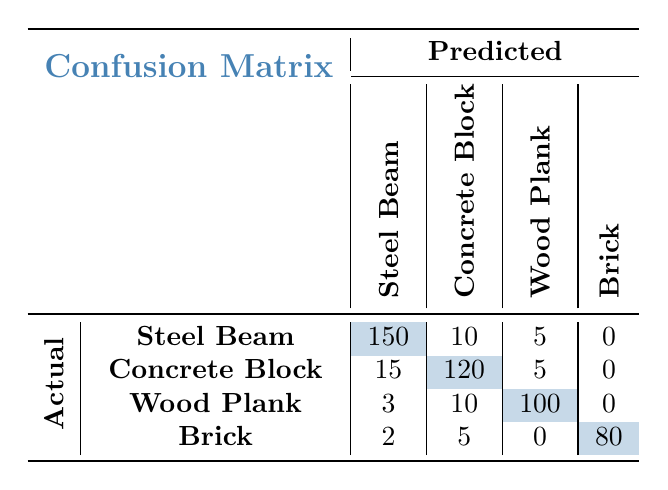What is the predicted outcome for “Steel Beam” when the actual outcome is also “Steel Beam”? The table shows that when the actual outcome is “Steel Beam”, the predicted outcome is also “Steel Beam” for 150 cases.
Answer: 150 What is the total count of "Concrete Block" actual outcomes predicted as "Wood Plank"? The table indicates that when the actual outcome is "Concrete Block", it was predicted as "Wood Plank" for 5 cases.
Answer: 5 What is the total number of actual "Wood Plank" loads predicted as something else (not "Wood Plank")? From the table, actual “Wood Plank” loads predicted as other materials are 3 (predicted as “Steel Beam”) + 10 (predicted as “Concrete Block”) = 13.
Answer: 13 Did any "Brick" loads get predicted accurately? The table shows that the actual "Brick" loads were predicted correctly for 80 cases. Hence, yes, there were accurate predictions.
Answer: Yes What is the overall accuracy for predicting "Concrete Block" loads? To calculate overall accuracy for "Concrete Block," we consider the correctly predicted outcomes (120) out of the total actual outcomes (120 + 15 + 5 = 140). So, the accuracy is 120/140 = 0.857 or 85.7%.
Answer: 85.7% How many total materials were predicted as “Steel Beam” regardless of the actual outcome? By adding together all cases predicted as "Steel Beam" from each actual category: 150 (Steel Beam) + 15 (Concrete Block) + 3 (Wood Plank) + 2 (Brick) = 170 predicted as "Steel Beam".
Answer: 170 Which material had the highest number of accurate predictions in this matrix? "Wood Plank" had the highest number of accurate predictions at 100 cases, as shown in the table.
Answer: Wood Plank What is the difference in count between actual "Concrete Block" and predicted "Concrete Block"? The table shows 120 actual "Concrete Block" loads were predicted correctly. Thus, the difference is 120 (actual) - 120 (predicted) = 0.
Answer: 0 How many cases were there where actual "Steel Beam" was mispredicted as "Concrete Block"? The table indicates that there were 10 instances where actual "Steel Beam" loads were predicted as "Concrete Block".
Answer: 10 